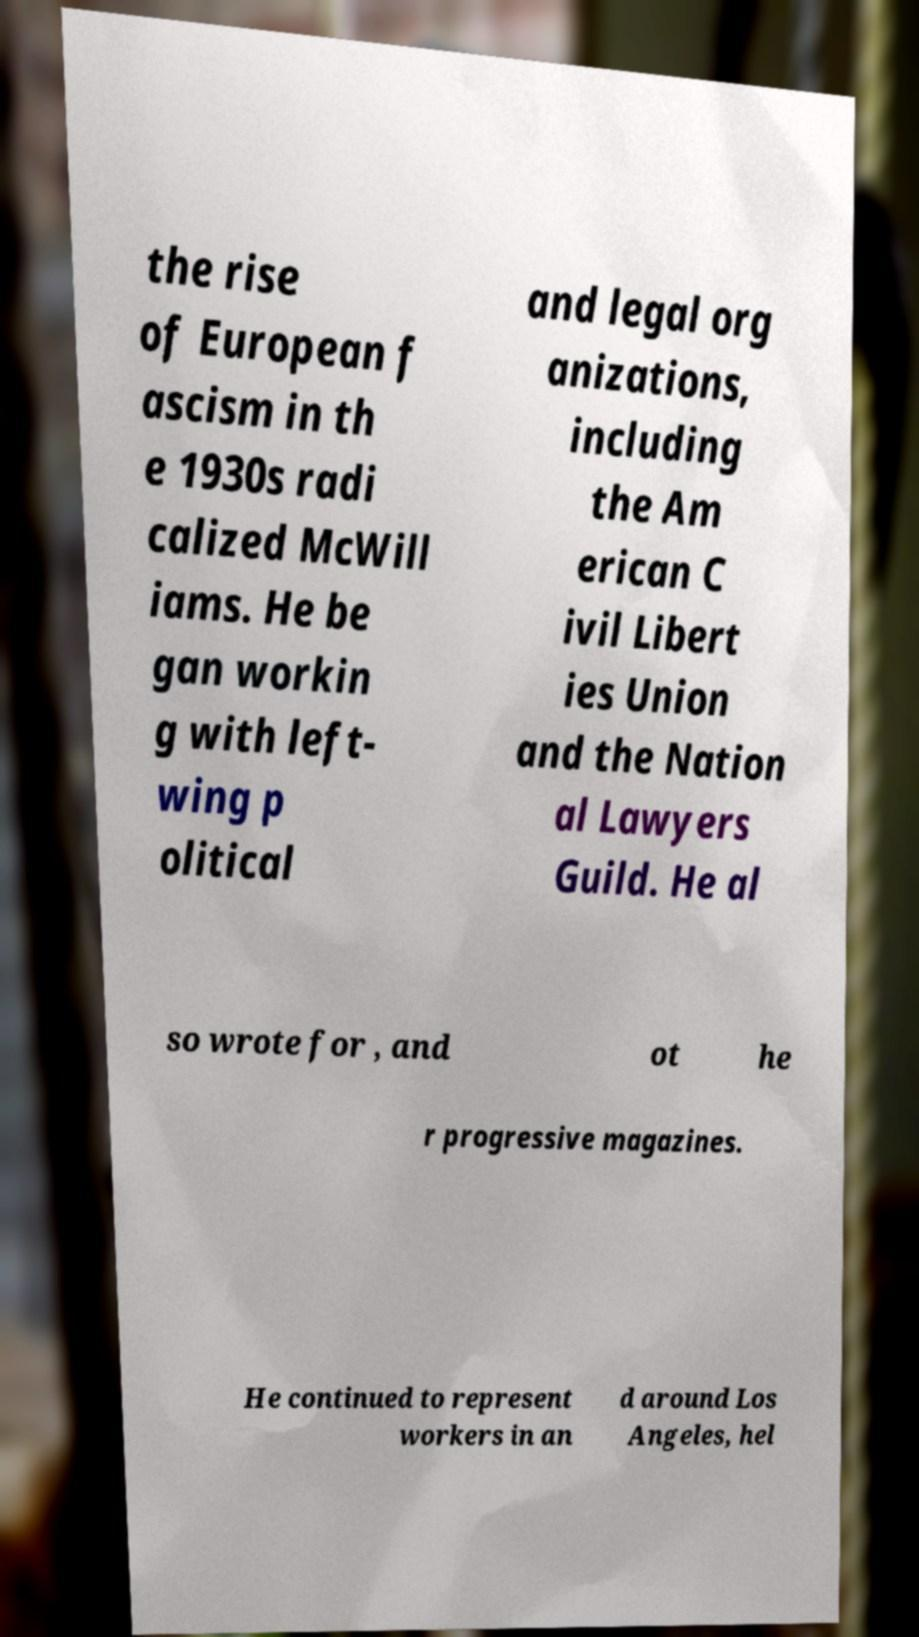I need the written content from this picture converted into text. Can you do that? the rise of European f ascism in th e 1930s radi calized McWill iams. He be gan workin g with left- wing p olitical and legal org anizations, including the Am erican C ivil Libert ies Union and the Nation al Lawyers Guild. He al so wrote for , and ot he r progressive magazines. He continued to represent workers in an d around Los Angeles, hel 